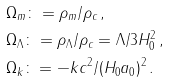<formula> <loc_0><loc_0><loc_500><loc_500>& \Omega _ { m } \colon = \rho _ { m } / \rho _ { c } \, , \\ & \Omega _ { \Lambda } \colon = \rho _ { \Lambda } / \rho _ { c } = \Lambda / 3 H _ { 0 } ^ { 2 } \, , \\ & \Omega _ { k } \colon = - k c ^ { 2 } / ( H _ { 0 } a _ { 0 } ) ^ { 2 } \, .</formula> 